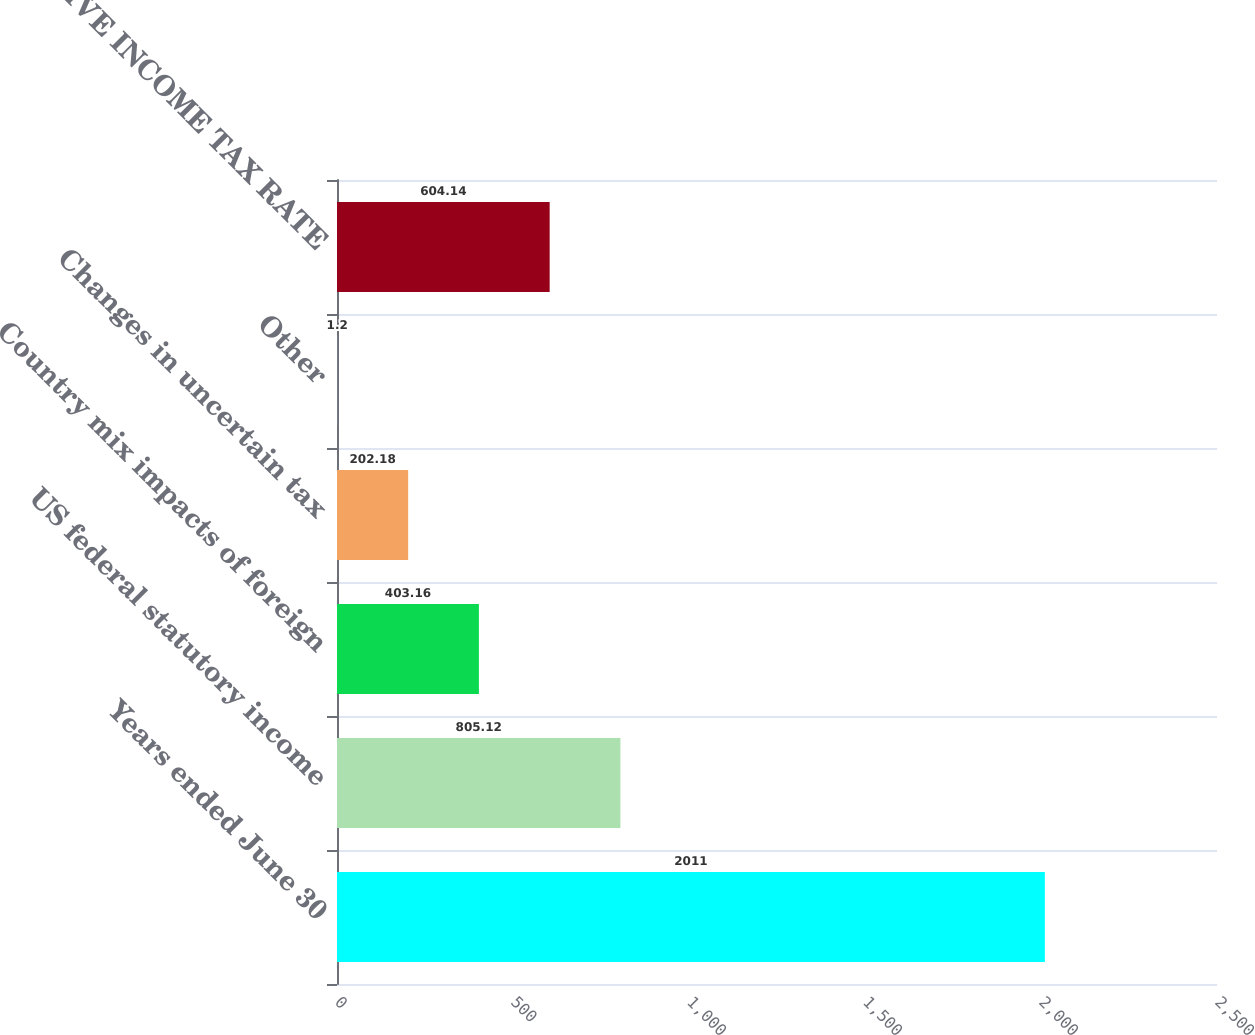<chart> <loc_0><loc_0><loc_500><loc_500><bar_chart><fcel>Years ended June 30<fcel>US federal statutory income<fcel>Country mix impacts of foreign<fcel>Changes in uncertain tax<fcel>Other<fcel>EFFECTIVE INCOME TAX RATE<nl><fcel>2011<fcel>805.12<fcel>403.16<fcel>202.18<fcel>1.2<fcel>604.14<nl></chart> 